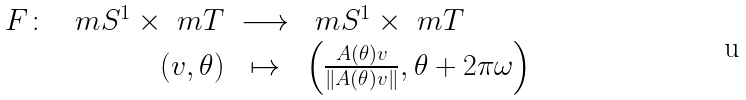Convert formula to latex. <formula><loc_0><loc_0><loc_500><loc_500>\begin{array} { r r c l } F \colon & \ m S ^ { 1 } \times \ m T & \longrightarrow & \ m S ^ { 1 } \times \ m T \\ & ( v , \theta ) & \mapsto & \left ( \frac { A ( \theta ) v } { \| A ( \theta ) v \| } , \theta + 2 \pi \omega \right ) \end{array}</formula> 